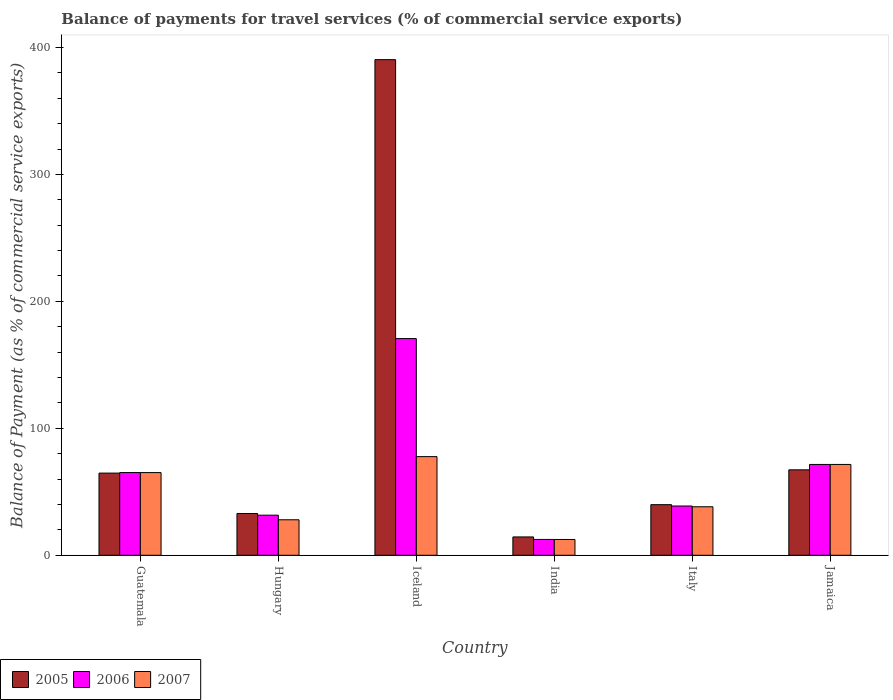How many groups of bars are there?
Provide a succinct answer. 6. How many bars are there on the 3rd tick from the right?
Your response must be concise. 3. In how many cases, is the number of bars for a given country not equal to the number of legend labels?
Provide a succinct answer. 0. What is the balance of payments for travel services in 2006 in Iceland?
Your answer should be compact. 170.69. Across all countries, what is the maximum balance of payments for travel services in 2006?
Provide a succinct answer. 170.69. Across all countries, what is the minimum balance of payments for travel services in 2005?
Provide a short and direct response. 14.45. What is the total balance of payments for travel services in 2007 in the graph?
Provide a short and direct response. 293.03. What is the difference between the balance of payments for travel services in 2007 in Hungary and that in India?
Offer a very short reply. 15.52. What is the difference between the balance of payments for travel services in 2007 in Jamaica and the balance of payments for travel services in 2005 in Hungary?
Your answer should be compact. 38.64. What is the average balance of payments for travel services in 2005 per country?
Give a very brief answer. 101.62. What is the difference between the balance of payments for travel services of/in 2006 and balance of payments for travel services of/in 2005 in Hungary?
Your answer should be very brief. -1.33. What is the ratio of the balance of payments for travel services in 2007 in Guatemala to that in Iceland?
Your answer should be compact. 0.84. Is the difference between the balance of payments for travel services in 2006 in Guatemala and Italy greater than the difference between the balance of payments for travel services in 2005 in Guatemala and Italy?
Ensure brevity in your answer.  Yes. What is the difference between the highest and the second highest balance of payments for travel services in 2006?
Give a very brief answer. -105.55. What is the difference between the highest and the lowest balance of payments for travel services in 2007?
Offer a very short reply. 65.28. In how many countries, is the balance of payments for travel services in 2006 greater than the average balance of payments for travel services in 2006 taken over all countries?
Offer a very short reply. 3. Is the sum of the balance of payments for travel services in 2005 in Guatemala and India greater than the maximum balance of payments for travel services in 2007 across all countries?
Offer a terse response. Yes. Is it the case that in every country, the sum of the balance of payments for travel services in 2005 and balance of payments for travel services in 2007 is greater than the balance of payments for travel services in 2006?
Your answer should be very brief. Yes. How many bars are there?
Ensure brevity in your answer.  18. How many countries are there in the graph?
Your response must be concise. 6. Does the graph contain grids?
Keep it short and to the point. No. How many legend labels are there?
Provide a short and direct response. 3. How are the legend labels stacked?
Provide a short and direct response. Horizontal. What is the title of the graph?
Keep it short and to the point. Balance of payments for travel services (% of commercial service exports). Does "1987" appear as one of the legend labels in the graph?
Your response must be concise. No. What is the label or title of the Y-axis?
Your response must be concise. Balance of Payment (as % of commercial service exports). What is the Balance of Payment (as % of commercial service exports) of 2005 in Guatemala?
Keep it short and to the point. 64.74. What is the Balance of Payment (as % of commercial service exports) of 2006 in Guatemala?
Make the answer very short. 65.15. What is the Balance of Payment (as % of commercial service exports) in 2007 in Guatemala?
Provide a short and direct response. 65.13. What is the Balance of Payment (as % of commercial service exports) in 2005 in Hungary?
Make the answer very short. 32.91. What is the Balance of Payment (as % of commercial service exports) of 2006 in Hungary?
Offer a very short reply. 31.58. What is the Balance of Payment (as % of commercial service exports) of 2007 in Hungary?
Provide a succinct answer. 27.96. What is the Balance of Payment (as % of commercial service exports) of 2005 in Iceland?
Ensure brevity in your answer.  390.42. What is the Balance of Payment (as % of commercial service exports) in 2006 in Iceland?
Your answer should be compact. 170.69. What is the Balance of Payment (as % of commercial service exports) in 2007 in Iceland?
Provide a succinct answer. 77.72. What is the Balance of Payment (as % of commercial service exports) of 2005 in India?
Provide a short and direct response. 14.45. What is the Balance of Payment (as % of commercial service exports) of 2006 in India?
Your answer should be very brief. 12.48. What is the Balance of Payment (as % of commercial service exports) of 2007 in India?
Your answer should be compact. 12.44. What is the Balance of Payment (as % of commercial service exports) of 2005 in Italy?
Offer a very short reply. 39.87. What is the Balance of Payment (as % of commercial service exports) of 2006 in Italy?
Provide a succinct answer. 38.81. What is the Balance of Payment (as % of commercial service exports) in 2007 in Italy?
Your answer should be compact. 38.22. What is the Balance of Payment (as % of commercial service exports) in 2005 in Jamaica?
Provide a short and direct response. 67.31. What is the Balance of Payment (as % of commercial service exports) in 2006 in Jamaica?
Ensure brevity in your answer.  71.55. What is the Balance of Payment (as % of commercial service exports) of 2007 in Jamaica?
Offer a terse response. 71.55. Across all countries, what is the maximum Balance of Payment (as % of commercial service exports) in 2005?
Provide a succinct answer. 390.42. Across all countries, what is the maximum Balance of Payment (as % of commercial service exports) of 2006?
Give a very brief answer. 170.69. Across all countries, what is the maximum Balance of Payment (as % of commercial service exports) of 2007?
Give a very brief answer. 77.72. Across all countries, what is the minimum Balance of Payment (as % of commercial service exports) of 2005?
Your response must be concise. 14.45. Across all countries, what is the minimum Balance of Payment (as % of commercial service exports) of 2006?
Your response must be concise. 12.48. Across all countries, what is the minimum Balance of Payment (as % of commercial service exports) of 2007?
Ensure brevity in your answer.  12.44. What is the total Balance of Payment (as % of commercial service exports) of 2005 in the graph?
Offer a very short reply. 609.71. What is the total Balance of Payment (as % of commercial service exports) in 2006 in the graph?
Your answer should be compact. 390.27. What is the total Balance of Payment (as % of commercial service exports) in 2007 in the graph?
Offer a very short reply. 293.03. What is the difference between the Balance of Payment (as % of commercial service exports) of 2005 in Guatemala and that in Hungary?
Your answer should be compact. 31.82. What is the difference between the Balance of Payment (as % of commercial service exports) in 2006 in Guatemala and that in Hungary?
Offer a very short reply. 33.57. What is the difference between the Balance of Payment (as % of commercial service exports) of 2007 in Guatemala and that in Hungary?
Provide a succinct answer. 37.17. What is the difference between the Balance of Payment (as % of commercial service exports) of 2005 in Guatemala and that in Iceland?
Offer a very short reply. -325.68. What is the difference between the Balance of Payment (as % of commercial service exports) in 2006 in Guatemala and that in Iceland?
Offer a terse response. -105.55. What is the difference between the Balance of Payment (as % of commercial service exports) of 2007 in Guatemala and that in Iceland?
Your response must be concise. -12.59. What is the difference between the Balance of Payment (as % of commercial service exports) of 2005 in Guatemala and that in India?
Make the answer very short. 50.29. What is the difference between the Balance of Payment (as % of commercial service exports) in 2006 in Guatemala and that in India?
Provide a succinct answer. 52.66. What is the difference between the Balance of Payment (as % of commercial service exports) in 2007 in Guatemala and that in India?
Your answer should be very brief. 52.69. What is the difference between the Balance of Payment (as % of commercial service exports) of 2005 in Guatemala and that in Italy?
Offer a very short reply. 24.86. What is the difference between the Balance of Payment (as % of commercial service exports) in 2006 in Guatemala and that in Italy?
Provide a short and direct response. 26.33. What is the difference between the Balance of Payment (as % of commercial service exports) in 2007 in Guatemala and that in Italy?
Give a very brief answer. 26.91. What is the difference between the Balance of Payment (as % of commercial service exports) of 2005 in Guatemala and that in Jamaica?
Ensure brevity in your answer.  -2.57. What is the difference between the Balance of Payment (as % of commercial service exports) in 2006 in Guatemala and that in Jamaica?
Your answer should be compact. -6.41. What is the difference between the Balance of Payment (as % of commercial service exports) in 2007 in Guatemala and that in Jamaica?
Provide a short and direct response. -6.42. What is the difference between the Balance of Payment (as % of commercial service exports) of 2005 in Hungary and that in Iceland?
Ensure brevity in your answer.  -357.51. What is the difference between the Balance of Payment (as % of commercial service exports) of 2006 in Hungary and that in Iceland?
Offer a terse response. -139.11. What is the difference between the Balance of Payment (as % of commercial service exports) in 2007 in Hungary and that in Iceland?
Ensure brevity in your answer.  -49.76. What is the difference between the Balance of Payment (as % of commercial service exports) of 2005 in Hungary and that in India?
Offer a terse response. 18.46. What is the difference between the Balance of Payment (as % of commercial service exports) in 2006 in Hungary and that in India?
Make the answer very short. 19.1. What is the difference between the Balance of Payment (as % of commercial service exports) in 2007 in Hungary and that in India?
Keep it short and to the point. 15.52. What is the difference between the Balance of Payment (as % of commercial service exports) in 2005 in Hungary and that in Italy?
Give a very brief answer. -6.96. What is the difference between the Balance of Payment (as % of commercial service exports) in 2006 in Hungary and that in Italy?
Offer a terse response. -7.24. What is the difference between the Balance of Payment (as % of commercial service exports) in 2007 in Hungary and that in Italy?
Your answer should be very brief. -10.26. What is the difference between the Balance of Payment (as % of commercial service exports) of 2005 in Hungary and that in Jamaica?
Your response must be concise. -34.4. What is the difference between the Balance of Payment (as % of commercial service exports) of 2006 in Hungary and that in Jamaica?
Give a very brief answer. -39.97. What is the difference between the Balance of Payment (as % of commercial service exports) of 2007 in Hungary and that in Jamaica?
Provide a short and direct response. -43.59. What is the difference between the Balance of Payment (as % of commercial service exports) of 2005 in Iceland and that in India?
Provide a short and direct response. 375.97. What is the difference between the Balance of Payment (as % of commercial service exports) in 2006 in Iceland and that in India?
Offer a terse response. 158.21. What is the difference between the Balance of Payment (as % of commercial service exports) in 2007 in Iceland and that in India?
Ensure brevity in your answer.  65.28. What is the difference between the Balance of Payment (as % of commercial service exports) in 2005 in Iceland and that in Italy?
Offer a terse response. 350.55. What is the difference between the Balance of Payment (as % of commercial service exports) in 2006 in Iceland and that in Italy?
Offer a terse response. 131.88. What is the difference between the Balance of Payment (as % of commercial service exports) in 2007 in Iceland and that in Italy?
Offer a very short reply. 39.49. What is the difference between the Balance of Payment (as % of commercial service exports) in 2005 in Iceland and that in Jamaica?
Your response must be concise. 323.11. What is the difference between the Balance of Payment (as % of commercial service exports) of 2006 in Iceland and that in Jamaica?
Keep it short and to the point. 99.14. What is the difference between the Balance of Payment (as % of commercial service exports) in 2007 in Iceland and that in Jamaica?
Keep it short and to the point. 6.17. What is the difference between the Balance of Payment (as % of commercial service exports) of 2005 in India and that in Italy?
Keep it short and to the point. -25.42. What is the difference between the Balance of Payment (as % of commercial service exports) in 2006 in India and that in Italy?
Your answer should be very brief. -26.33. What is the difference between the Balance of Payment (as % of commercial service exports) in 2007 in India and that in Italy?
Ensure brevity in your answer.  -25.78. What is the difference between the Balance of Payment (as % of commercial service exports) in 2005 in India and that in Jamaica?
Offer a terse response. -52.86. What is the difference between the Balance of Payment (as % of commercial service exports) of 2006 in India and that in Jamaica?
Give a very brief answer. -59.07. What is the difference between the Balance of Payment (as % of commercial service exports) in 2007 in India and that in Jamaica?
Keep it short and to the point. -59.11. What is the difference between the Balance of Payment (as % of commercial service exports) of 2005 in Italy and that in Jamaica?
Make the answer very short. -27.44. What is the difference between the Balance of Payment (as % of commercial service exports) of 2006 in Italy and that in Jamaica?
Keep it short and to the point. -32.74. What is the difference between the Balance of Payment (as % of commercial service exports) of 2007 in Italy and that in Jamaica?
Your answer should be very brief. -33.32. What is the difference between the Balance of Payment (as % of commercial service exports) in 2005 in Guatemala and the Balance of Payment (as % of commercial service exports) in 2006 in Hungary?
Offer a terse response. 33.16. What is the difference between the Balance of Payment (as % of commercial service exports) of 2005 in Guatemala and the Balance of Payment (as % of commercial service exports) of 2007 in Hungary?
Make the answer very short. 36.77. What is the difference between the Balance of Payment (as % of commercial service exports) of 2006 in Guatemala and the Balance of Payment (as % of commercial service exports) of 2007 in Hungary?
Offer a very short reply. 37.18. What is the difference between the Balance of Payment (as % of commercial service exports) of 2005 in Guatemala and the Balance of Payment (as % of commercial service exports) of 2006 in Iceland?
Ensure brevity in your answer.  -105.96. What is the difference between the Balance of Payment (as % of commercial service exports) in 2005 in Guatemala and the Balance of Payment (as % of commercial service exports) in 2007 in Iceland?
Provide a succinct answer. -12.98. What is the difference between the Balance of Payment (as % of commercial service exports) of 2006 in Guatemala and the Balance of Payment (as % of commercial service exports) of 2007 in Iceland?
Your answer should be compact. -12.57. What is the difference between the Balance of Payment (as % of commercial service exports) of 2005 in Guatemala and the Balance of Payment (as % of commercial service exports) of 2006 in India?
Your response must be concise. 52.25. What is the difference between the Balance of Payment (as % of commercial service exports) in 2005 in Guatemala and the Balance of Payment (as % of commercial service exports) in 2007 in India?
Offer a terse response. 52.3. What is the difference between the Balance of Payment (as % of commercial service exports) of 2006 in Guatemala and the Balance of Payment (as % of commercial service exports) of 2007 in India?
Give a very brief answer. 52.7. What is the difference between the Balance of Payment (as % of commercial service exports) of 2005 in Guatemala and the Balance of Payment (as % of commercial service exports) of 2006 in Italy?
Your answer should be very brief. 25.92. What is the difference between the Balance of Payment (as % of commercial service exports) in 2005 in Guatemala and the Balance of Payment (as % of commercial service exports) in 2007 in Italy?
Give a very brief answer. 26.51. What is the difference between the Balance of Payment (as % of commercial service exports) of 2006 in Guatemala and the Balance of Payment (as % of commercial service exports) of 2007 in Italy?
Offer a terse response. 26.92. What is the difference between the Balance of Payment (as % of commercial service exports) of 2005 in Guatemala and the Balance of Payment (as % of commercial service exports) of 2006 in Jamaica?
Offer a terse response. -6.82. What is the difference between the Balance of Payment (as % of commercial service exports) in 2005 in Guatemala and the Balance of Payment (as % of commercial service exports) in 2007 in Jamaica?
Provide a succinct answer. -6.81. What is the difference between the Balance of Payment (as % of commercial service exports) in 2006 in Guatemala and the Balance of Payment (as % of commercial service exports) in 2007 in Jamaica?
Ensure brevity in your answer.  -6.4. What is the difference between the Balance of Payment (as % of commercial service exports) of 2005 in Hungary and the Balance of Payment (as % of commercial service exports) of 2006 in Iceland?
Ensure brevity in your answer.  -137.78. What is the difference between the Balance of Payment (as % of commercial service exports) of 2005 in Hungary and the Balance of Payment (as % of commercial service exports) of 2007 in Iceland?
Offer a terse response. -44.81. What is the difference between the Balance of Payment (as % of commercial service exports) of 2006 in Hungary and the Balance of Payment (as % of commercial service exports) of 2007 in Iceland?
Offer a terse response. -46.14. What is the difference between the Balance of Payment (as % of commercial service exports) of 2005 in Hungary and the Balance of Payment (as % of commercial service exports) of 2006 in India?
Offer a terse response. 20.43. What is the difference between the Balance of Payment (as % of commercial service exports) in 2005 in Hungary and the Balance of Payment (as % of commercial service exports) in 2007 in India?
Your response must be concise. 20.47. What is the difference between the Balance of Payment (as % of commercial service exports) of 2006 in Hungary and the Balance of Payment (as % of commercial service exports) of 2007 in India?
Offer a very short reply. 19.14. What is the difference between the Balance of Payment (as % of commercial service exports) in 2005 in Hungary and the Balance of Payment (as % of commercial service exports) in 2006 in Italy?
Provide a succinct answer. -5.9. What is the difference between the Balance of Payment (as % of commercial service exports) of 2005 in Hungary and the Balance of Payment (as % of commercial service exports) of 2007 in Italy?
Provide a short and direct response. -5.31. What is the difference between the Balance of Payment (as % of commercial service exports) of 2006 in Hungary and the Balance of Payment (as % of commercial service exports) of 2007 in Italy?
Your response must be concise. -6.64. What is the difference between the Balance of Payment (as % of commercial service exports) in 2005 in Hungary and the Balance of Payment (as % of commercial service exports) in 2006 in Jamaica?
Give a very brief answer. -38.64. What is the difference between the Balance of Payment (as % of commercial service exports) of 2005 in Hungary and the Balance of Payment (as % of commercial service exports) of 2007 in Jamaica?
Provide a succinct answer. -38.64. What is the difference between the Balance of Payment (as % of commercial service exports) of 2006 in Hungary and the Balance of Payment (as % of commercial service exports) of 2007 in Jamaica?
Provide a succinct answer. -39.97. What is the difference between the Balance of Payment (as % of commercial service exports) in 2005 in Iceland and the Balance of Payment (as % of commercial service exports) in 2006 in India?
Keep it short and to the point. 377.94. What is the difference between the Balance of Payment (as % of commercial service exports) of 2005 in Iceland and the Balance of Payment (as % of commercial service exports) of 2007 in India?
Keep it short and to the point. 377.98. What is the difference between the Balance of Payment (as % of commercial service exports) in 2006 in Iceland and the Balance of Payment (as % of commercial service exports) in 2007 in India?
Ensure brevity in your answer.  158.25. What is the difference between the Balance of Payment (as % of commercial service exports) of 2005 in Iceland and the Balance of Payment (as % of commercial service exports) of 2006 in Italy?
Offer a very short reply. 351.61. What is the difference between the Balance of Payment (as % of commercial service exports) in 2005 in Iceland and the Balance of Payment (as % of commercial service exports) in 2007 in Italy?
Your answer should be very brief. 352.2. What is the difference between the Balance of Payment (as % of commercial service exports) in 2006 in Iceland and the Balance of Payment (as % of commercial service exports) in 2007 in Italy?
Your response must be concise. 132.47. What is the difference between the Balance of Payment (as % of commercial service exports) of 2005 in Iceland and the Balance of Payment (as % of commercial service exports) of 2006 in Jamaica?
Your answer should be very brief. 318.87. What is the difference between the Balance of Payment (as % of commercial service exports) in 2005 in Iceland and the Balance of Payment (as % of commercial service exports) in 2007 in Jamaica?
Provide a short and direct response. 318.87. What is the difference between the Balance of Payment (as % of commercial service exports) of 2006 in Iceland and the Balance of Payment (as % of commercial service exports) of 2007 in Jamaica?
Give a very brief answer. 99.15. What is the difference between the Balance of Payment (as % of commercial service exports) in 2005 in India and the Balance of Payment (as % of commercial service exports) in 2006 in Italy?
Offer a terse response. -24.36. What is the difference between the Balance of Payment (as % of commercial service exports) of 2005 in India and the Balance of Payment (as % of commercial service exports) of 2007 in Italy?
Offer a terse response. -23.77. What is the difference between the Balance of Payment (as % of commercial service exports) in 2006 in India and the Balance of Payment (as % of commercial service exports) in 2007 in Italy?
Offer a terse response. -25.74. What is the difference between the Balance of Payment (as % of commercial service exports) of 2005 in India and the Balance of Payment (as % of commercial service exports) of 2006 in Jamaica?
Your response must be concise. -57.1. What is the difference between the Balance of Payment (as % of commercial service exports) in 2005 in India and the Balance of Payment (as % of commercial service exports) in 2007 in Jamaica?
Provide a succinct answer. -57.1. What is the difference between the Balance of Payment (as % of commercial service exports) in 2006 in India and the Balance of Payment (as % of commercial service exports) in 2007 in Jamaica?
Your answer should be very brief. -59.07. What is the difference between the Balance of Payment (as % of commercial service exports) of 2005 in Italy and the Balance of Payment (as % of commercial service exports) of 2006 in Jamaica?
Your response must be concise. -31.68. What is the difference between the Balance of Payment (as % of commercial service exports) in 2005 in Italy and the Balance of Payment (as % of commercial service exports) in 2007 in Jamaica?
Your answer should be compact. -31.68. What is the difference between the Balance of Payment (as % of commercial service exports) in 2006 in Italy and the Balance of Payment (as % of commercial service exports) in 2007 in Jamaica?
Your answer should be compact. -32.73. What is the average Balance of Payment (as % of commercial service exports) of 2005 per country?
Offer a terse response. 101.62. What is the average Balance of Payment (as % of commercial service exports) in 2006 per country?
Keep it short and to the point. 65.05. What is the average Balance of Payment (as % of commercial service exports) of 2007 per country?
Offer a terse response. 48.84. What is the difference between the Balance of Payment (as % of commercial service exports) of 2005 and Balance of Payment (as % of commercial service exports) of 2006 in Guatemala?
Offer a very short reply. -0.41. What is the difference between the Balance of Payment (as % of commercial service exports) in 2005 and Balance of Payment (as % of commercial service exports) in 2007 in Guatemala?
Give a very brief answer. -0.4. What is the difference between the Balance of Payment (as % of commercial service exports) of 2006 and Balance of Payment (as % of commercial service exports) of 2007 in Guatemala?
Your answer should be compact. 0.01. What is the difference between the Balance of Payment (as % of commercial service exports) in 2005 and Balance of Payment (as % of commercial service exports) in 2006 in Hungary?
Your response must be concise. 1.33. What is the difference between the Balance of Payment (as % of commercial service exports) in 2005 and Balance of Payment (as % of commercial service exports) in 2007 in Hungary?
Offer a terse response. 4.95. What is the difference between the Balance of Payment (as % of commercial service exports) in 2006 and Balance of Payment (as % of commercial service exports) in 2007 in Hungary?
Offer a very short reply. 3.62. What is the difference between the Balance of Payment (as % of commercial service exports) in 2005 and Balance of Payment (as % of commercial service exports) in 2006 in Iceland?
Ensure brevity in your answer.  219.73. What is the difference between the Balance of Payment (as % of commercial service exports) in 2005 and Balance of Payment (as % of commercial service exports) in 2007 in Iceland?
Your answer should be compact. 312.7. What is the difference between the Balance of Payment (as % of commercial service exports) in 2006 and Balance of Payment (as % of commercial service exports) in 2007 in Iceland?
Provide a short and direct response. 92.98. What is the difference between the Balance of Payment (as % of commercial service exports) of 2005 and Balance of Payment (as % of commercial service exports) of 2006 in India?
Provide a succinct answer. 1.97. What is the difference between the Balance of Payment (as % of commercial service exports) in 2005 and Balance of Payment (as % of commercial service exports) in 2007 in India?
Make the answer very short. 2.01. What is the difference between the Balance of Payment (as % of commercial service exports) of 2006 and Balance of Payment (as % of commercial service exports) of 2007 in India?
Keep it short and to the point. 0.04. What is the difference between the Balance of Payment (as % of commercial service exports) in 2005 and Balance of Payment (as % of commercial service exports) in 2006 in Italy?
Your answer should be compact. 1.06. What is the difference between the Balance of Payment (as % of commercial service exports) in 2005 and Balance of Payment (as % of commercial service exports) in 2007 in Italy?
Your response must be concise. 1.65. What is the difference between the Balance of Payment (as % of commercial service exports) of 2006 and Balance of Payment (as % of commercial service exports) of 2007 in Italy?
Give a very brief answer. 0.59. What is the difference between the Balance of Payment (as % of commercial service exports) in 2005 and Balance of Payment (as % of commercial service exports) in 2006 in Jamaica?
Keep it short and to the point. -4.24. What is the difference between the Balance of Payment (as % of commercial service exports) in 2005 and Balance of Payment (as % of commercial service exports) in 2007 in Jamaica?
Your answer should be very brief. -4.24. What is the difference between the Balance of Payment (as % of commercial service exports) of 2006 and Balance of Payment (as % of commercial service exports) of 2007 in Jamaica?
Make the answer very short. 0.01. What is the ratio of the Balance of Payment (as % of commercial service exports) in 2005 in Guatemala to that in Hungary?
Offer a terse response. 1.97. What is the ratio of the Balance of Payment (as % of commercial service exports) in 2006 in Guatemala to that in Hungary?
Offer a terse response. 2.06. What is the ratio of the Balance of Payment (as % of commercial service exports) in 2007 in Guatemala to that in Hungary?
Give a very brief answer. 2.33. What is the ratio of the Balance of Payment (as % of commercial service exports) of 2005 in Guatemala to that in Iceland?
Provide a short and direct response. 0.17. What is the ratio of the Balance of Payment (as % of commercial service exports) of 2006 in Guatemala to that in Iceland?
Offer a terse response. 0.38. What is the ratio of the Balance of Payment (as % of commercial service exports) in 2007 in Guatemala to that in Iceland?
Give a very brief answer. 0.84. What is the ratio of the Balance of Payment (as % of commercial service exports) in 2005 in Guatemala to that in India?
Your response must be concise. 4.48. What is the ratio of the Balance of Payment (as % of commercial service exports) in 2006 in Guatemala to that in India?
Provide a succinct answer. 5.22. What is the ratio of the Balance of Payment (as % of commercial service exports) in 2007 in Guatemala to that in India?
Keep it short and to the point. 5.23. What is the ratio of the Balance of Payment (as % of commercial service exports) of 2005 in Guatemala to that in Italy?
Provide a short and direct response. 1.62. What is the ratio of the Balance of Payment (as % of commercial service exports) in 2006 in Guatemala to that in Italy?
Provide a short and direct response. 1.68. What is the ratio of the Balance of Payment (as % of commercial service exports) of 2007 in Guatemala to that in Italy?
Your response must be concise. 1.7. What is the ratio of the Balance of Payment (as % of commercial service exports) of 2005 in Guatemala to that in Jamaica?
Your response must be concise. 0.96. What is the ratio of the Balance of Payment (as % of commercial service exports) of 2006 in Guatemala to that in Jamaica?
Keep it short and to the point. 0.91. What is the ratio of the Balance of Payment (as % of commercial service exports) of 2007 in Guatemala to that in Jamaica?
Your answer should be compact. 0.91. What is the ratio of the Balance of Payment (as % of commercial service exports) in 2005 in Hungary to that in Iceland?
Provide a succinct answer. 0.08. What is the ratio of the Balance of Payment (as % of commercial service exports) of 2006 in Hungary to that in Iceland?
Your answer should be compact. 0.18. What is the ratio of the Balance of Payment (as % of commercial service exports) in 2007 in Hungary to that in Iceland?
Keep it short and to the point. 0.36. What is the ratio of the Balance of Payment (as % of commercial service exports) in 2005 in Hungary to that in India?
Offer a very short reply. 2.28. What is the ratio of the Balance of Payment (as % of commercial service exports) in 2006 in Hungary to that in India?
Provide a short and direct response. 2.53. What is the ratio of the Balance of Payment (as % of commercial service exports) in 2007 in Hungary to that in India?
Your answer should be very brief. 2.25. What is the ratio of the Balance of Payment (as % of commercial service exports) in 2005 in Hungary to that in Italy?
Provide a short and direct response. 0.83. What is the ratio of the Balance of Payment (as % of commercial service exports) of 2006 in Hungary to that in Italy?
Your answer should be very brief. 0.81. What is the ratio of the Balance of Payment (as % of commercial service exports) of 2007 in Hungary to that in Italy?
Make the answer very short. 0.73. What is the ratio of the Balance of Payment (as % of commercial service exports) of 2005 in Hungary to that in Jamaica?
Offer a terse response. 0.49. What is the ratio of the Balance of Payment (as % of commercial service exports) of 2006 in Hungary to that in Jamaica?
Offer a terse response. 0.44. What is the ratio of the Balance of Payment (as % of commercial service exports) of 2007 in Hungary to that in Jamaica?
Provide a short and direct response. 0.39. What is the ratio of the Balance of Payment (as % of commercial service exports) of 2005 in Iceland to that in India?
Make the answer very short. 27.02. What is the ratio of the Balance of Payment (as % of commercial service exports) in 2006 in Iceland to that in India?
Your response must be concise. 13.67. What is the ratio of the Balance of Payment (as % of commercial service exports) of 2007 in Iceland to that in India?
Keep it short and to the point. 6.25. What is the ratio of the Balance of Payment (as % of commercial service exports) of 2005 in Iceland to that in Italy?
Give a very brief answer. 9.79. What is the ratio of the Balance of Payment (as % of commercial service exports) in 2006 in Iceland to that in Italy?
Your response must be concise. 4.4. What is the ratio of the Balance of Payment (as % of commercial service exports) in 2007 in Iceland to that in Italy?
Offer a terse response. 2.03. What is the ratio of the Balance of Payment (as % of commercial service exports) of 2005 in Iceland to that in Jamaica?
Your answer should be very brief. 5.8. What is the ratio of the Balance of Payment (as % of commercial service exports) of 2006 in Iceland to that in Jamaica?
Your answer should be compact. 2.39. What is the ratio of the Balance of Payment (as % of commercial service exports) of 2007 in Iceland to that in Jamaica?
Offer a very short reply. 1.09. What is the ratio of the Balance of Payment (as % of commercial service exports) of 2005 in India to that in Italy?
Make the answer very short. 0.36. What is the ratio of the Balance of Payment (as % of commercial service exports) in 2006 in India to that in Italy?
Your response must be concise. 0.32. What is the ratio of the Balance of Payment (as % of commercial service exports) in 2007 in India to that in Italy?
Your response must be concise. 0.33. What is the ratio of the Balance of Payment (as % of commercial service exports) of 2005 in India to that in Jamaica?
Offer a terse response. 0.21. What is the ratio of the Balance of Payment (as % of commercial service exports) in 2006 in India to that in Jamaica?
Provide a succinct answer. 0.17. What is the ratio of the Balance of Payment (as % of commercial service exports) of 2007 in India to that in Jamaica?
Offer a terse response. 0.17. What is the ratio of the Balance of Payment (as % of commercial service exports) in 2005 in Italy to that in Jamaica?
Your response must be concise. 0.59. What is the ratio of the Balance of Payment (as % of commercial service exports) in 2006 in Italy to that in Jamaica?
Keep it short and to the point. 0.54. What is the ratio of the Balance of Payment (as % of commercial service exports) in 2007 in Italy to that in Jamaica?
Your answer should be compact. 0.53. What is the difference between the highest and the second highest Balance of Payment (as % of commercial service exports) in 2005?
Make the answer very short. 323.11. What is the difference between the highest and the second highest Balance of Payment (as % of commercial service exports) in 2006?
Provide a short and direct response. 99.14. What is the difference between the highest and the second highest Balance of Payment (as % of commercial service exports) in 2007?
Your answer should be very brief. 6.17. What is the difference between the highest and the lowest Balance of Payment (as % of commercial service exports) of 2005?
Offer a very short reply. 375.97. What is the difference between the highest and the lowest Balance of Payment (as % of commercial service exports) in 2006?
Your answer should be compact. 158.21. What is the difference between the highest and the lowest Balance of Payment (as % of commercial service exports) of 2007?
Your response must be concise. 65.28. 